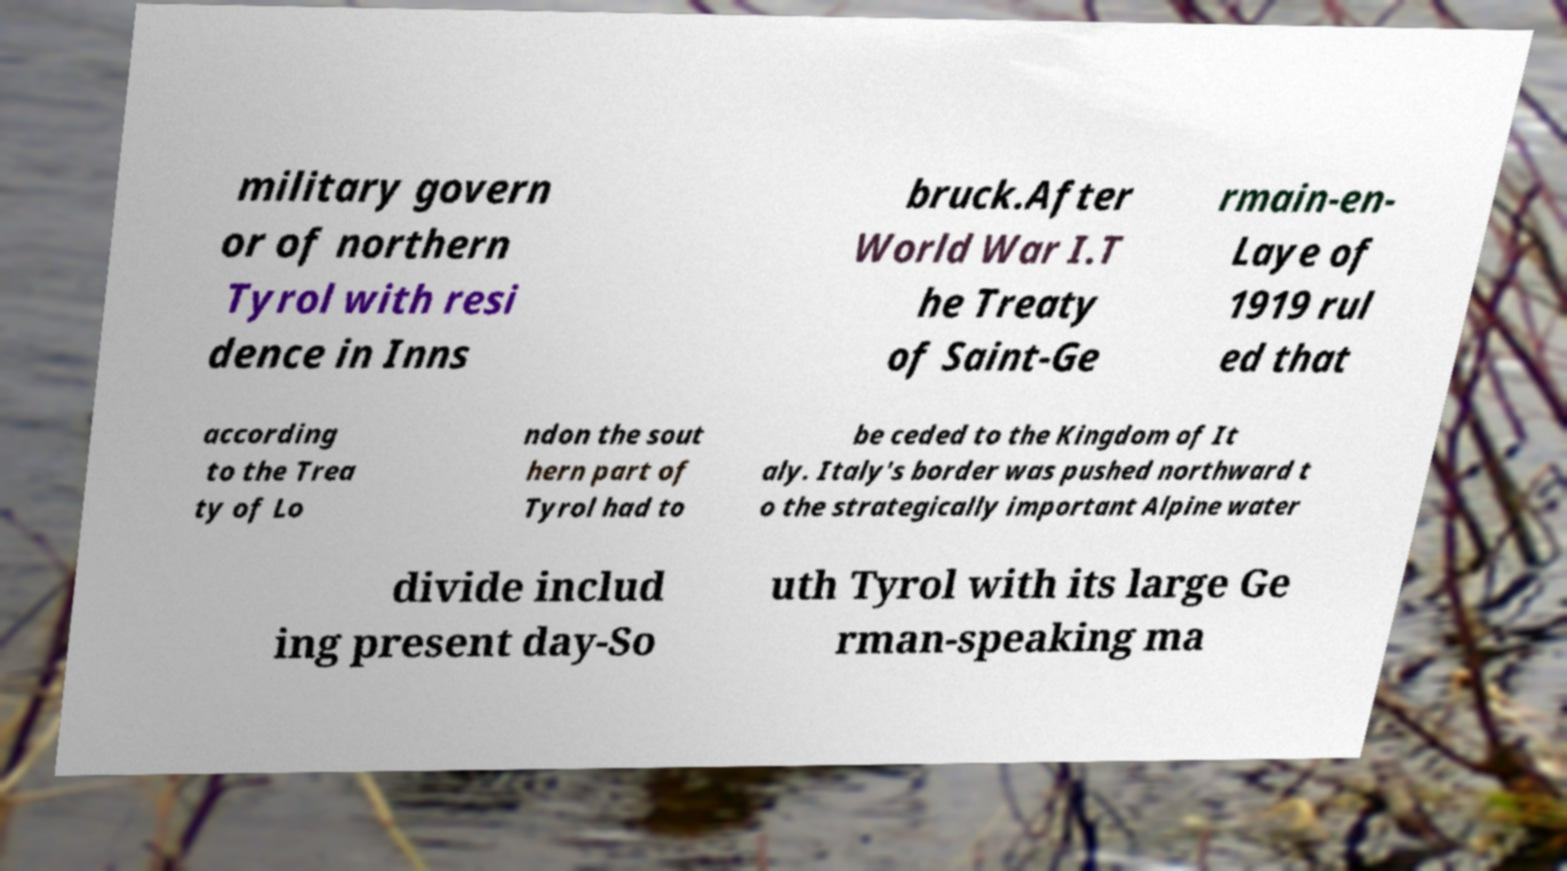For documentation purposes, I need the text within this image transcribed. Could you provide that? military govern or of northern Tyrol with resi dence in Inns bruck.After World War I.T he Treaty of Saint-Ge rmain-en- Laye of 1919 rul ed that according to the Trea ty of Lo ndon the sout hern part of Tyrol had to be ceded to the Kingdom of It aly. Italy's border was pushed northward t o the strategically important Alpine water divide includ ing present day-So uth Tyrol with its large Ge rman-speaking ma 